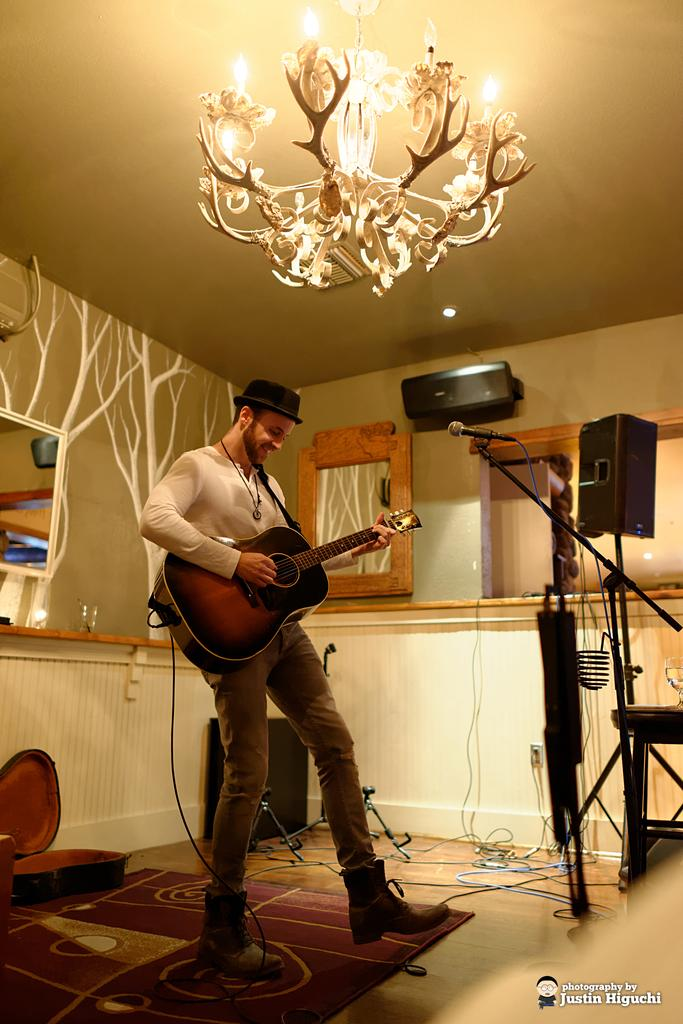What is the main setting of the image? There is a room in the image. What is the person in the room doing? The person is playing a guitar. Can you describe the person's appearance? The person is wearing a cap. What can be seen in the background of the room? There are lights, a curtain, and a window visible in the background. What type of pump is visible in the image? There is no pump present in the image. Is there a birthday celebration happening in the image? There is no indication of a birthday celebration in the image. 